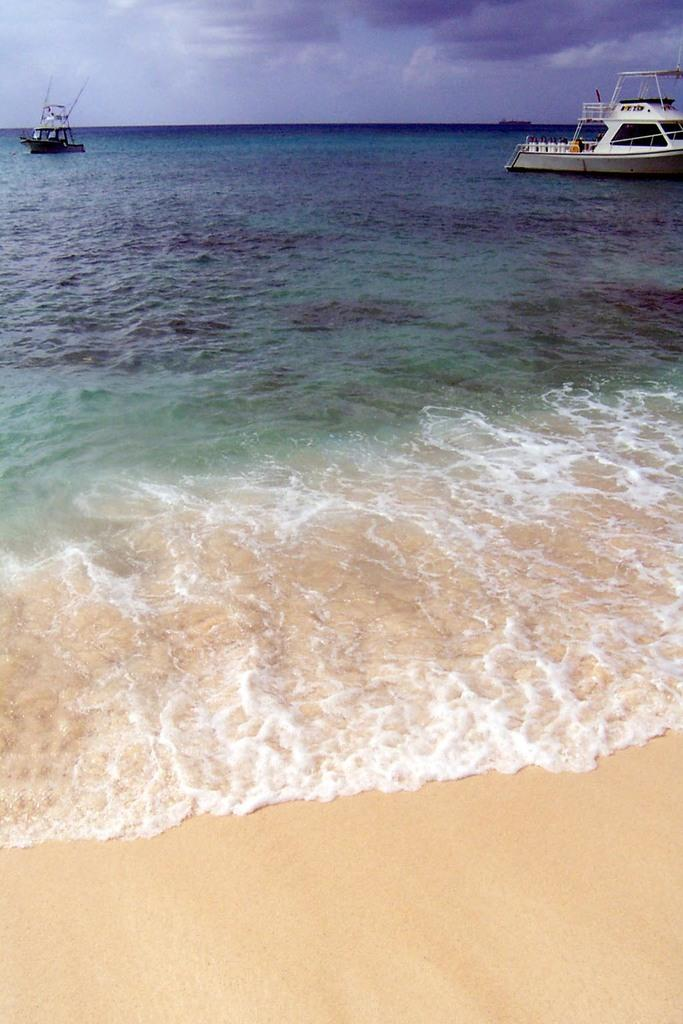What is at the bottom of the image? There is sand at the bottom of the image. What is in the middle of the image? There is water in the middle of the image. What can be seen floating on the water? There are two boats in the water. What is visible at the top of the image? The sky is visible at the top of the image. What can be observed in the sky? Clouds are present in the sky. Can you see the face of the person pulling the sack in the image? There is no person pulling a sack in the image; it features sand, water, boats, sky, and clouds. 